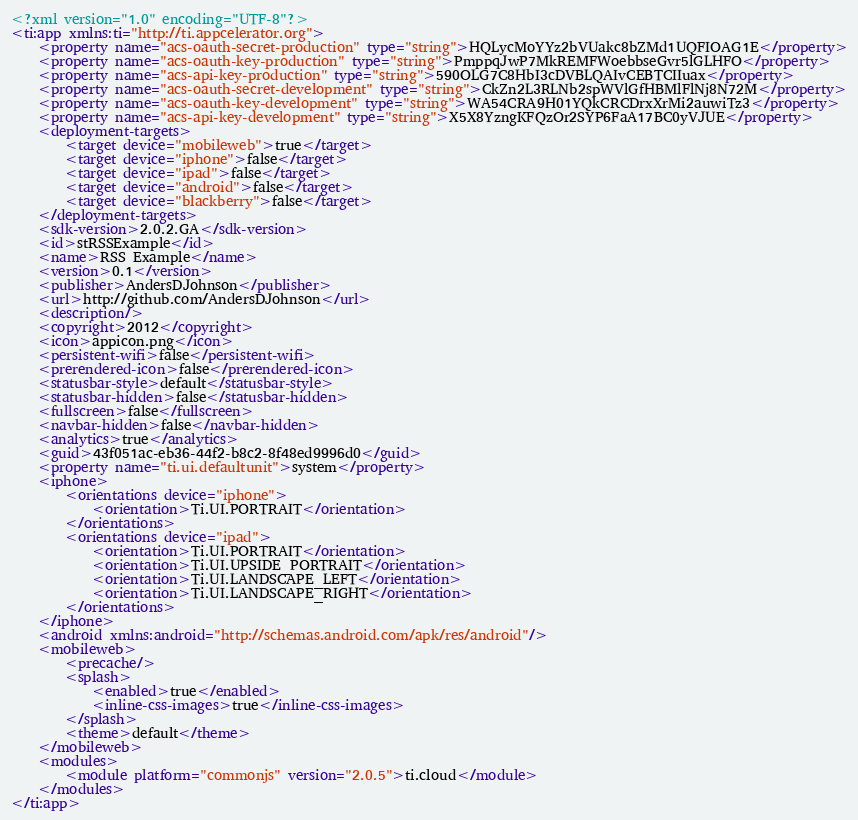Convert code to text. <code><loc_0><loc_0><loc_500><loc_500><_XML_><?xml version="1.0" encoding="UTF-8"?>
<ti:app xmlns:ti="http://ti.appcelerator.org">
    <property name="acs-oauth-secret-production" type="string">HQLycMoYYz2bVUakc8bZMd1UQFIOAG1E</property>
    <property name="acs-oauth-key-production" type="string">PmppqJwP7MkREMFWoebbseGvr5lGLHFO</property>
    <property name="acs-api-key-production" type="string">590OLG7C8HbI3cDVBLQAIvCEBTCIIuax</property>
    <property name="acs-oauth-secret-development" type="string">CkZn2L3RLNb2spWVlGfHBMlFlNj8N72M</property>
    <property name="acs-oauth-key-development" type="string">WA54CRA9H01YQkCRCDrxXrMi2auwiTz3</property>
    <property name="acs-api-key-development" type="string">X5X8YzngKFQzOr2SYP6FaA17BC0yVJUE</property>
    <deployment-targets>
        <target device="mobileweb">true</target>
        <target device="iphone">false</target>
        <target device="ipad">false</target>
        <target device="android">false</target>
        <target device="blackberry">false</target>
    </deployment-targets>
    <sdk-version>2.0.2.GA</sdk-version>
    <id>stRSSExample</id>
    <name>RSS Example</name>
    <version>0.1</version>
    <publisher>AndersDJohnson</publisher>
    <url>http://github.com/AndersDJohnson</url>
    <description/>
    <copyright>2012</copyright>
    <icon>appicon.png</icon>
    <persistent-wifi>false</persistent-wifi>
    <prerendered-icon>false</prerendered-icon>
    <statusbar-style>default</statusbar-style>
    <statusbar-hidden>false</statusbar-hidden>
    <fullscreen>false</fullscreen>
    <navbar-hidden>false</navbar-hidden>
    <analytics>true</analytics>
    <guid>43f051ac-eb36-44f2-b8c2-8f48ed9996d0</guid>
    <property name="ti.ui.defaultunit">system</property>
    <iphone>
        <orientations device="iphone">
            <orientation>Ti.UI.PORTRAIT</orientation>
        </orientations>
        <orientations device="ipad">
            <orientation>Ti.UI.PORTRAIT</orientation>
            <orientation>Ti.UI.UPSIDE_PORTRAIT</orientation>
            <orientation>Ti.UI.LANDSCAPE_LEFT</orientation>
            <orientation>Ti.UI.LANDSCAPE_RIGHT</orientation>
        </orientations>
    </iphone>
    <android xmlns:android="http://schemas.android.com/apk/res/android"/>
    <mobileweb>
        <precache/>
        <splash>
            <enabled>true</enabled>
            <inline-css-images>true</inline-css-images>
        </splash>
        <theme>default</theme>
    </mobileweb>
    <modules>
        <module platform="commonjs" version="2.0.5">ti.cloud</module>
    </modules>
</ti:app>
</code> 